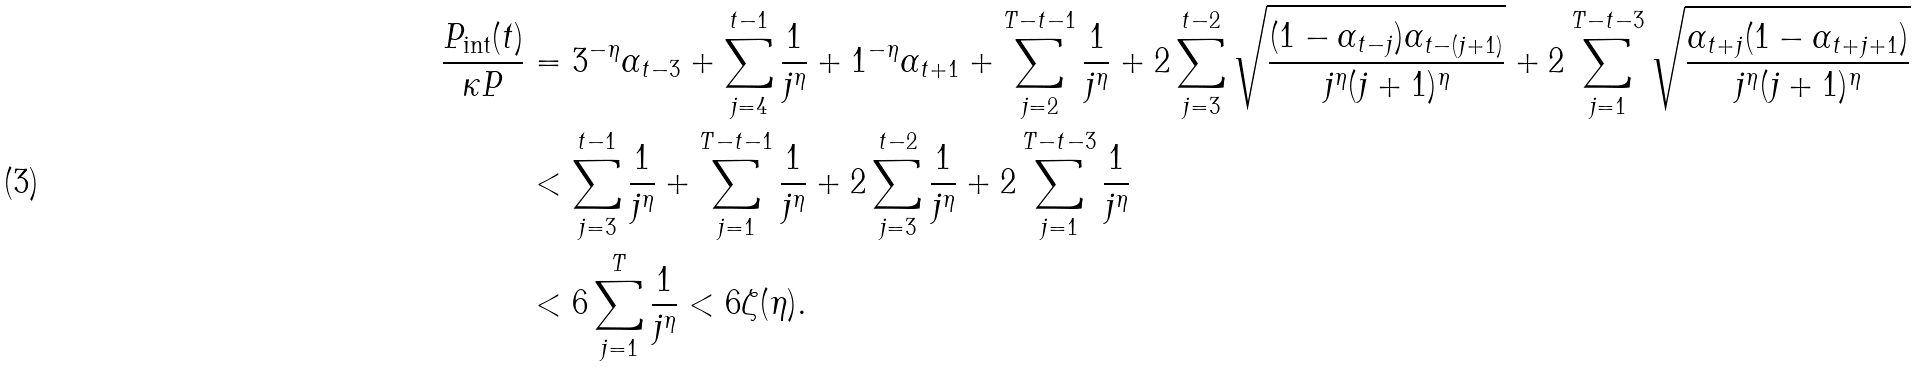<formula> <loc_0><loc_0><loc_500><loc_500>\frac { P _ { \text {int} } ( t ) } { \kappa P } & = 3 ^ { - \eta } \alpha _ { t - 3 } + \sum _ { j = 4 } ^ { t - 1 } \frac { 1 } { j ^ { \eta } } + 1 ^ { - \eta } \alpha _ { t + 1 } + \sum _ { j = 2 } ^ { T - t - 1 } \frac { 1 } { j ^ { \eta } } + 2 \sum _ { j = 3 } ^ { t - 2 } \sqrt { \frac { ( 1 - \alpha _ { t - j } ) \alpha _ { t - ( j + 1 ) } } { j ^ { \eta } ( j + 1 ) ^ { \eta } } } + 2 \sum _ { j = 1 } ^ { T - t - 3 } \sqrt { \frac { \alpha _ { t + j } ( 1 - \alpha _ { t + j + 1 } ) } { j ^ { \eta } ( j + 1 ) ^ { \eta } } } \\ & < \sum _ { j = 3 } ^ { t - 1 } \frac { 1 } { j ^ { \eta } } + \sum _ { j = 1 } ^ { T - t - 1 } \frac { 1 } { j ^ { \eta } } + 2 \sum _ { j = 3 } ^ { t - 2 } \frac { 1 } { j ^ { \eta } } + 2 \sum _ { j = 1 } ^ { T - t - 3 } \frac { 1 } { j ^ { \eta } } \\ & < 6 \sum _ { j = 1 } ^ { T } \frac { 1 } { j ^ { \eta } } < 6 \zeta ( \eta ) .</formula> 